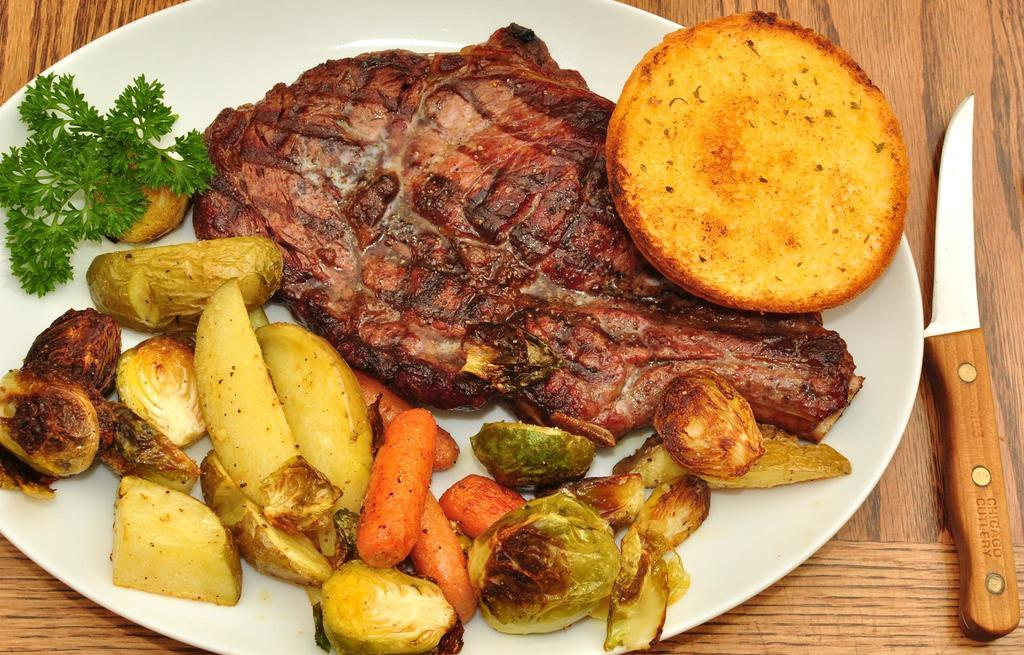What is on the plate in the image? There are carrots, potato slices, and a leafy vegetable on the plate. What is the knife used for in the image? The knife is on the table, which suggests it might be used for cutting or preparing food. What type of food is on the plate? There is some food on the plate, including carrots, potato slices, and a leafy vegetable. Can you hear the trick being played on the plate in the image? There is no trick or sound present in the image, as it is a still image of a plate with food and a knife on the table. 